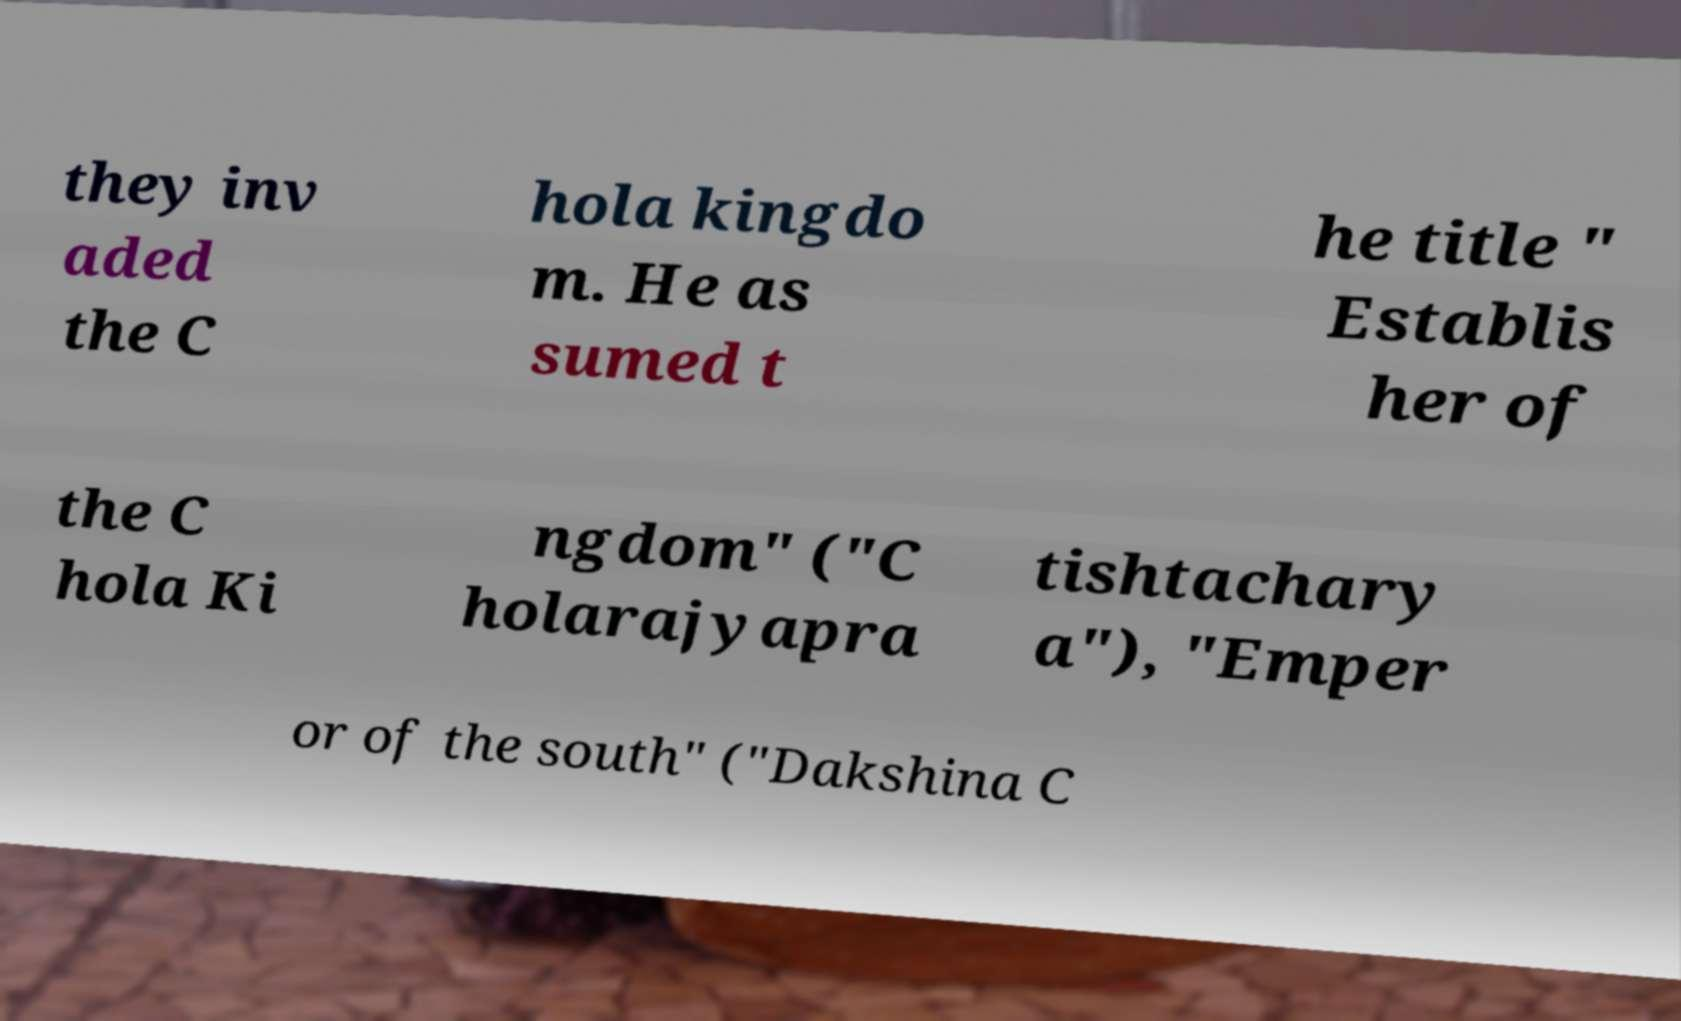What messages or text are displayed in this image? I need them in a readable, typed format. they inv aded the C hola kingdo m. He as sumed t he title " Establis her of the C hola Ki ngdom" ("C holarajyapra tishtachary a"), "Emper or of the south" ("Dakshina C 